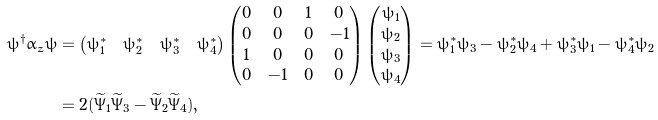Convert formula to latex. <formula><loc_0><loc_0><loc_500><loc_500>\psi ^ { \dagger } \alpha _ { z } \psi & = \left ( \begin{matrix} \psi _ { 1 } ^ { \ast } & \psi _ { 2 } ^ { \ast } & \psi _ { 3 } ^ { \ast } & \psi _ { 4 } ^ { \ast } \end{matrix} \right ) \left ( \begin{matrix} 0 & 0 & 1 & 0 \\ 0 & 0 & 0 & - 1 \\ 1 & 0 & 0 & 0 \\ 0 & - 1 & 0 & 0 \end{matrix} \right ) \left ( \begin{matrix} \psi _ { 1 } \\ \psi _ { 2 } \\ \psi _ { 3 } \\ \psi _ { 4 } \end{matrix} \right ) = \psi _ { 1 } ^ { \ast } \psi _ { 3 } - \psi _ { 2 } ^ { \ast } \psi _ { 4 } + \psi _ { 3 } ^ { \ast } \psi _ { 1 } - \psi _ { 4 } ^ { \ast } \psi _ { 2 } \\ & = 2 ( \widetilde { \Psi } _ { 1 } \widetilde { \Psi } _ { 3 } - \widetilde { \Psi } _ { 2 } \widetilde { \Psi } _ { 4 } ) ,</formula> 